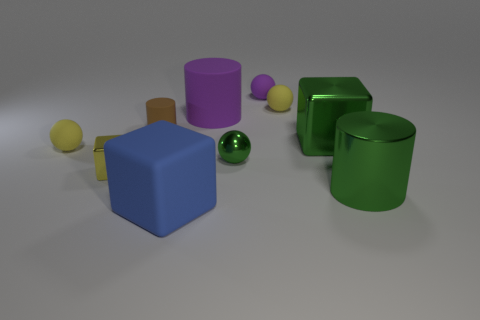What number of spheres are in front of the large cube that is behind the big rubber block?
Ensure brevity in your answer.  2. What number of metal objects are large purple objects or cyan blocks?
Make the answer very short. 0. Is there a big green cylinder made of the same material as the tiny yellow cube?
Give a very brief answer. Yes. How many objects are tiny yellow rubber objects that are behind the green cube or yellow things right of the big blue block?
Ensure brevity in your answer.  1. There is a block that is to the right of the tiny green object; is it the same color as the metal cylinder?
Provide a succinct answer. Yes. How many other things are there of the same color as the tiny metallic ball?
Give a very brief answer. 2. What material is the green cylinder?
Your response must be concise. Metal. There is a yellow rubber sphere behind the brown matte cylinder; is its size the same as the large blue rubber block?
Offer a very short reply. No. Is there anything else that is the same size as the green cube?
Offer a very short reply. Yes. What size is the green metallic object that is the same shape as the small purple rubber object?
Your response must be concise. Small. 